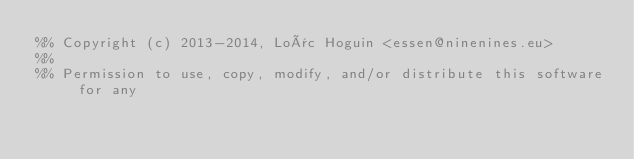Convert code to text. <code><loc_0><loc_0><loc_500><loc_500><_Erlang_>%% Copyright (c) 2013-2014, Loïc Hoguin <essen@ninenines.eu>
%%
%% Permission to use, copy, modify, and/or distribute this software for any</code> 